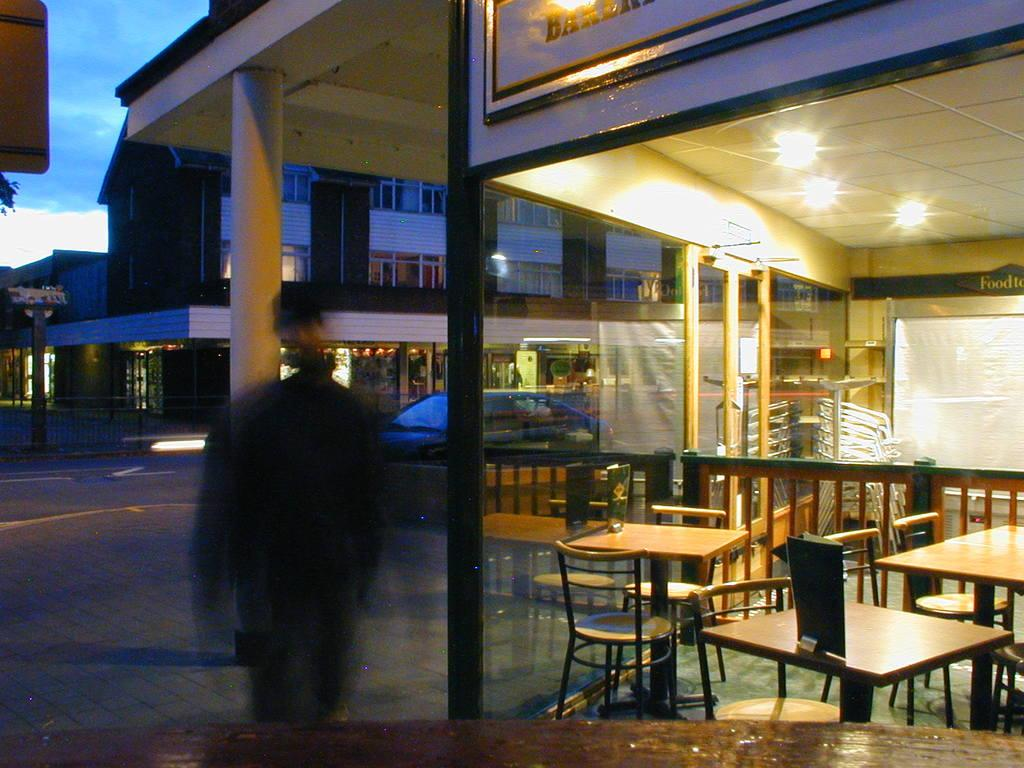What type of furniture can be seen in the image? There are tables and chairs in the image. What type of structure is present in the image? There is a fence, poles, and buildings in the image. What type of surface is visible in the image? There is pavement in the image. What type of vehicle is present in the image? There is a car in the image. Are there any people visible in the image? Yes, there is a person in the image. What part of the sky is visible in the image? The sky is visible in the left top of the image. How many mice are sitting on the jar in the image? There are no mice or jars present in the image. Is there a window visible in the image? No, there is no window visible in the image. 